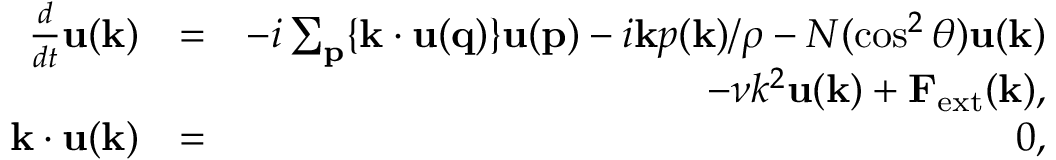<formula> <loc_0><loc_0><loc_500><loc_500>\begin{array} { r l r } { \frac { d } { d t } { u ( k ) } } & { = } & { - i \sum _ { p } \{ { k \cdot u ( q ) } \} { u ( p ) } - i { k } p ( { k } ) / \rho - N ( \cos ^ { 2 } \theta ) { u ( k ) } } \\ & { - \nu k ^ { 2 } { u ( k ) } + { F } _ { e x t } ( { k } ) , } \\ { k \cdot u ( k ) } & { = } & { 0 , } \end{array}</formula> 